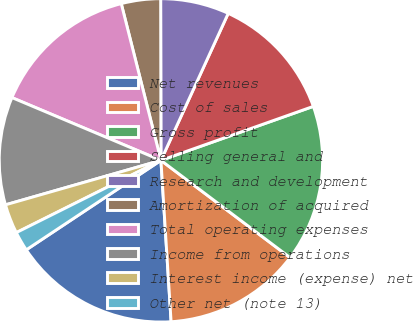<chart> <loc_0><loc_0><loc_500><loc_500><pie_chart><fcel>Net revenues<fcel>Cost of sales<fcel>Gross profit<fcel>Selling general and<fcel>Research and development<fcel>Amortization of acquired<fcel>Total operating expenses<fcel>Income from operations<fcel>Interest income (expense) net<fcel>Other net (note 13)<nl><fcel>16.67%<fcel>13.73%<fcel>15.69%<fcel>12.75%<fcel>6.86%<fcel>3.92%<fcel>14.71%<fcel>10.78%<fcel>2.94%<fcel>1.96%<nl></chart> 